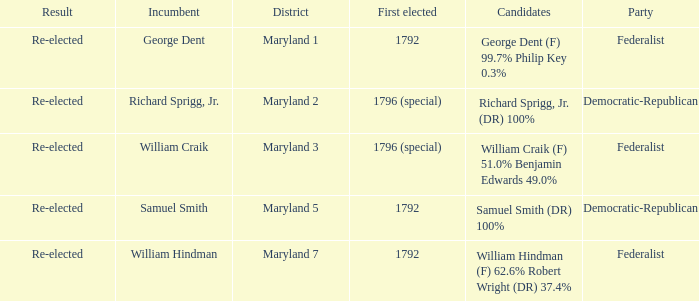 What is the result for the district Maryland 7? Re-elected. 